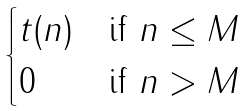Convert formula to latex. <formula><loc_0><loc_0><loc_500><loc_500>\begin{cases} t ( n ) & \text {if $n \leq M$} \\ 0 & \text {if $n>M$} \end{cases}</formula> 